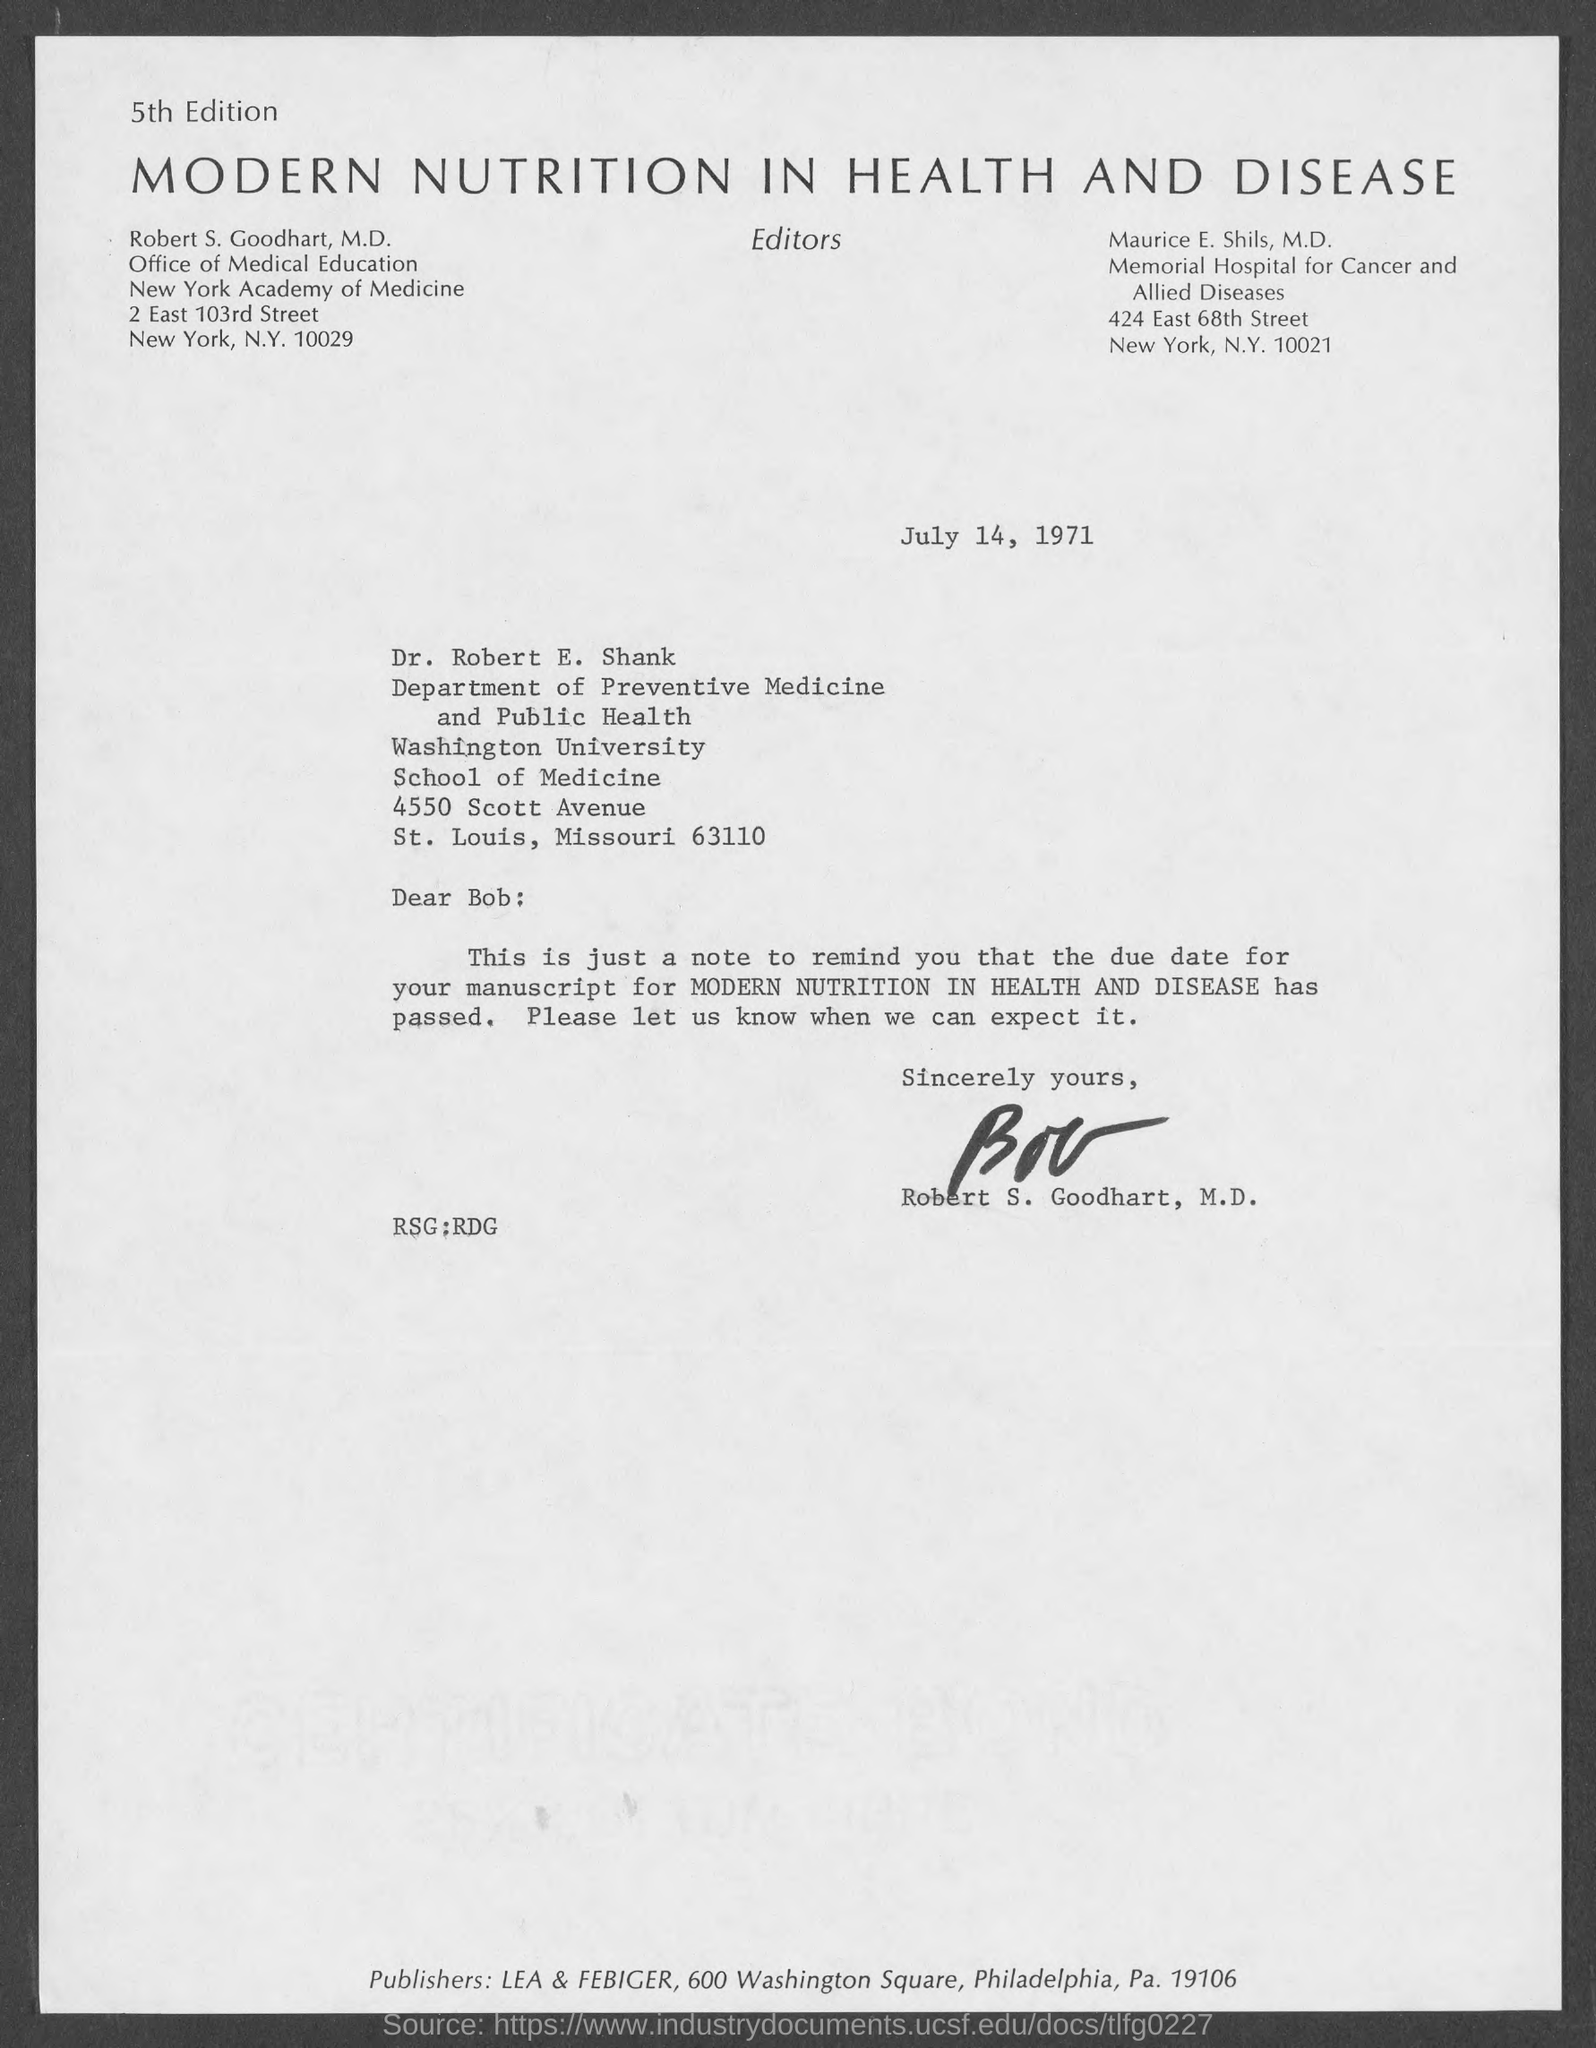Point out several critical features in this image. The date on the document is July 14, 1971. The manuscript due is named "Modern Nutrition in Health and Disease. The letter is addressed to Bob. The letter is from Robert S. Goodhart, M.D. 